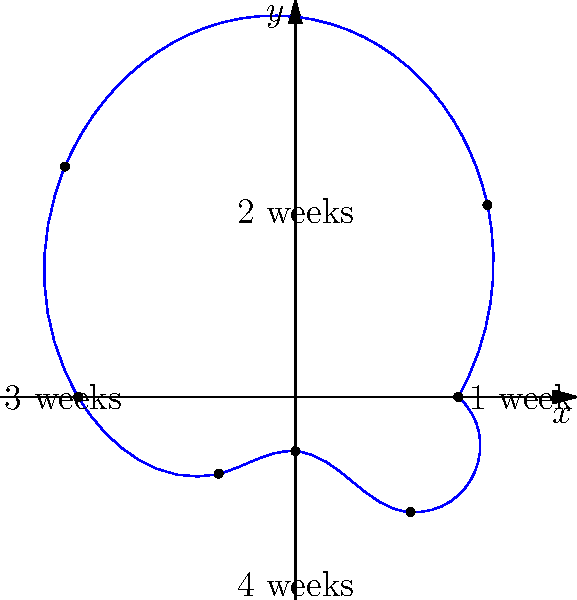As a psychiatrist studying the effects of acting on mental health, you're monitoring a patient's anxiety symptoms over a 4-week period. The intensity of symptoms is plotted using polar coordinates, where the angle represents time (0° to 360° for 4 weeks) and the radius represents symptom intensity (0-7 scale). At which point in time does the patient experience the highest intensity of anxiety symptoms? To determine when the patient experiences the highest intensity of anxiety symptoms, we need to analyze the polar plot:

1. The plot shows a complete 360° rotation, representing 4 weeks of time.
2. Each 90° segment represents approximately 1 week.
3. The radial distance from the center represents the intensity of symptoms on a scale of 0-7.
4. We need to identify the point furthest from the center, as this represents the highest intensity.

Analyzing the plot:
- At 0° (start): r ≈ 3
- At 45° (0.5 weeks): r ≈ 5
- At 90° (1 week): r ≈ 7 (highest point)
- At 135° (1.5 weeks): r ≈ 6
- At 180° (2 weeks): r ≈ 4
- At 225° (2.5 weeks): r ≈ 2
- At 270° (3 weeks): r ≈ 1
- At 315° (3.5 weeks): r ≈ 3
- At 360° (4 weeks): r ≈ 3

The point furthest from the center occurs at 90°, which corresponds to the end of week 1.
Answer: End of week 1 